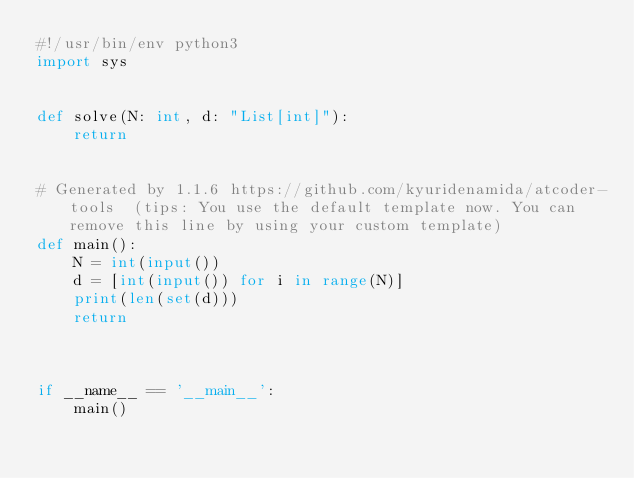Convert code to text. <code><loc_0><loc_0><loc_500><loc_500><_Python_>#!/usr/bin/env python3
import sys


def solve(N: int, d: "List[int]"):
    return


# Generated by 1.1.6 https://github.com/kyuridenamida/atcoder-tools  (tips: You use the default template now. You can remove this line by using your custom template)
def main():
    N = int(input())
    d = [int(input()) for i in range(N)]
    print(len(set(d)))
    return



if __name__ == '__main__':
    main()
</code> 